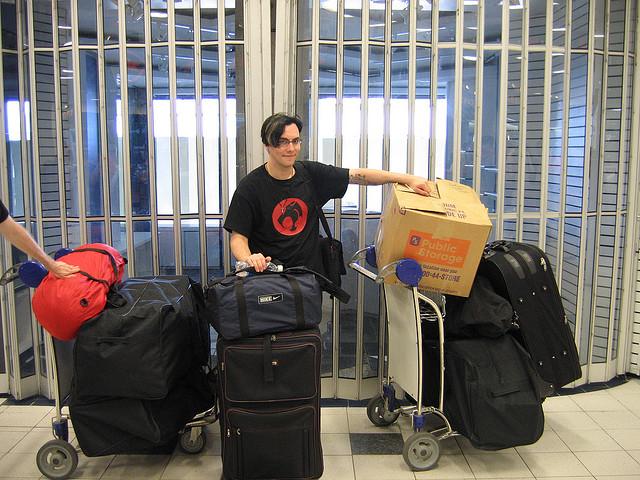What is the flooring made of?
Short answer required. Tile. Is all the luggage on luggage carts?
Quick response, please. No. What does the box say that the man is holding with his left hand?
Be succinct. Public storage. 